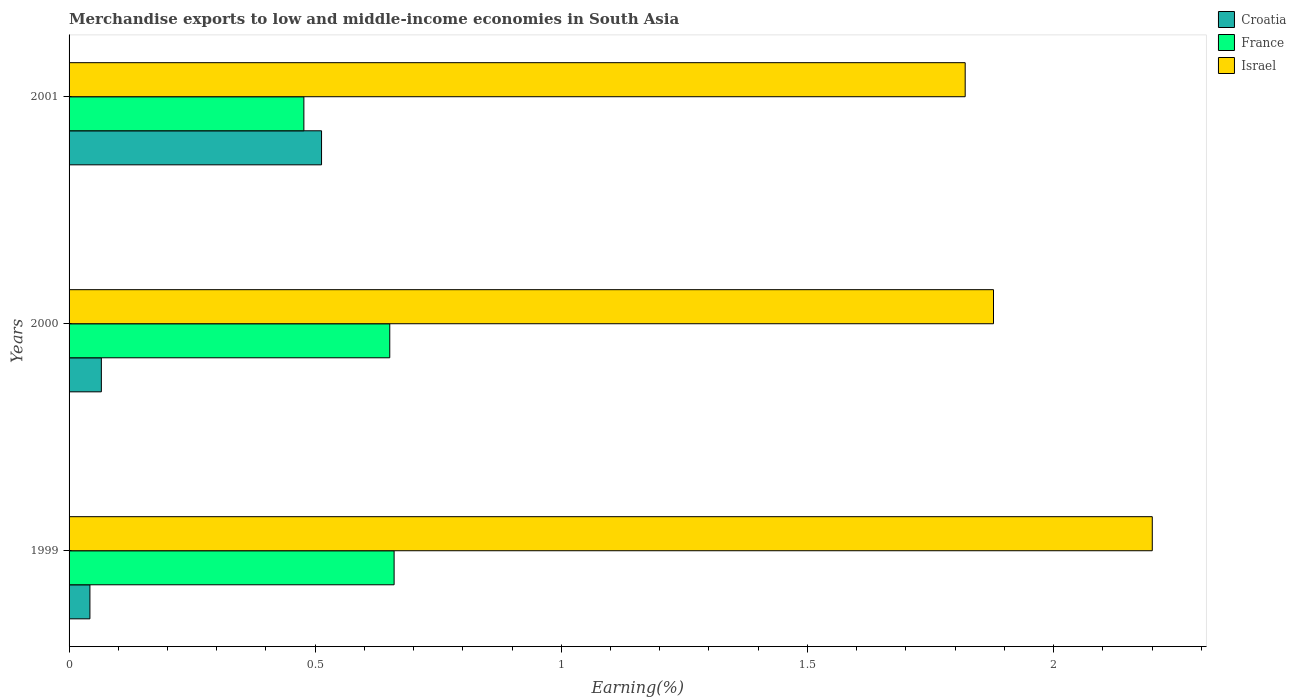Are the number of bars per tick equal to the number of legend labels?
Your answer should be compact. Yes. How many bars are there on the 1st tick from the top?
Keep it short and to the point. 3. What is the percentage of amount earned from merchandise exports in Israel in 2000?
Provide a short and direct response. 1.88. Across all years, what is the maximum percentage of amount earned from merchandise exports in Croatia?
Make the answer very short. 0.51. Across all years, what is the minimum percentage of amount earned from merchandise exports in France?
Your answer should be very brief. 0.48. What is the total percentage of amount earned from merchandise exports in Croatia in the graph?
Make the answer very short. 0.62. What is the difference between the percentage of amount earned from merchandise exports in France in 1999 and that in 2001?
Keep it short and to the point. 0.18. What is the difference between the percentage of amount earned from merchandise exports in Croatia in 2000 and the percentage of amount earned from merchandise exports in France in 2001?
Provide a succinct answer. -0.41. What is the average percentage of amount earned from merchandise exports in Croatia per year?
Your answer should be compact. 0.21. In the year 2000, what is the difference between the percentage of amount earned from merchandise exports in France and percentage of amount earned from merchandise exports in Croatia?
Make the answer very short. 0.59. What is the ratio of the percentage of amount earned from merchandise exports in France in 1999 to that in 2001?
Give a very brief answer. 1.38. Is the percentage of amount earned from merchandise exports in Israel in 1999 less than that in 2001?
Give a very brief answer. No. What is the difference between the highest and the second highest percentage of amount earned from merchandise exports in France?
Your response must be concise. 0.01. What is the difference between the highest and the lowest percentage of amount earned from merchandise exports in Israel?
Your answer should be very brief. 0.38. What does the 3rd bar from the top in 1999 represents?
Provide a succinct answer. Croatia. How many bars are there?
Provide a short and direct response. 9. Are all the bars in the graph horizontal?
Offer a very short reply. Yes. How many years are there in the graph?
Ensure brevity in your answer.  3. What is the difference between two consecutive major ticks on the X-axis?
Your answer should be compact. 0.5. Are the values on the major ticks of X-axis written in scientific E-notation?
Ensure brevity in your answer.  No. Does the graph contain any zero values?
Give a very brief answer. No. Where does the legend appear in the graph?
Your answer should be compact. Top right. How many legend labels are there?
Provide a short and direct response. 3. How are the legend labels stacked?
Your response must be concise. Vertical. What is the title of the graph?
Your answer should be compact. Merchandise exports to low and middle-income economies in South Asia. What is the label or title of the X-axis?
Provide a succinct answer. Earning(%). What is the Earning(%) in Croatia in 1999?
Your answer should be very brief. 0.04. What is the Earning(%) of France in 1999?
Ensure brevity in your answer.  0.66. What is the Earning(%) in Israel in 1999?
Your answer should be compact. 2.2. What is the Earning(%) of Croatia in 2000?
Offer a very short reply. 0.07. What is the Earning(%) of France in 2000?
Provide a short and direct response. 0.65. What is the Earning(%) of Israel in 2000?
Your response must be concise. 1.88. What is the Earning(%) of Croatia in 2001?
Make the answer very short. 0.51. What is the Earning(%) in France in 2001?
Ensure brevity in your answer.  0.48. What is the Earning(%) of Israel in 2001?
Your answer should be very brief. 1.82. Across all years, what is the maximum Earning(%) in Croatia?
Keep it short and to the point. 0.51. Across all years, what is the maximum Earning(%) of France?
Your answer should be compact. 0.66. Across all years, what is the maximum Earning(%) in Israel?
Ensure brevity in your answer.  2.2. Across all years, what is the minimum Earning(%) in Croatia?
Ensure brevity in your answer.  0.04. Across all years, what is the minimum Earning(%) of France?
Ensure brevity in your answer.  0.48. Across all years, what is the minimum Earning(%) of Israel?
Your answer should be very brief. 1.82. What is the total Earning(%) of Croatia in the graph?
Provide a succinct answer. 0.62. What is the total Earning(%) in France in the graph?
Your answer should be very brief. 1.79. What is the total Earning(%) of Israel in the graph?
Provide a succinct answer. 5.9. What is the difference between the Earning(%) in Croatia in 1999 and that in 2000?
Offer a very short reply. -0.02. What is the difference between the Earning(%) of France in 1999 and that in 2000?
Your answer should be compact. 0.01. What is the difference between the Earning(%) in Israel in 1999 and that in 2000?
Ensure brevity in your answer.  0.32. What is the difference between the Earning(%) in Croatia in 1999 and that in 2001?
Your response must be concise. -0.47. What is the difference between the Earning(%) in France in 1999 and that in 2001?
Offer a terse response. 0.18. What is the difference between the Earning(%) of Israel in 1999 and that in 2001?
Ensure brevity in your answer.  0.38. What is the difference between the Earning(%) in Croatia in 2000 and that in 2001?
Offer a terse response. -0.45. What is the difference between the Earning(%) of France in 2000 and that in 2001?
Keep it short and to the point. 0.17. What is the difference between the Earning(%) of Israel in 2000 and that in 2001?
Offer a very short reply. 0.06. What is the difference between the Earning(%) in Croatia in 1999 and the Earning(%) in France in 2000?
Your answer should be compact. -0.61. What is the difference between the Earning(%) in Croatia in 1999 and the Earning(%) in Israel in 2000?
Ensure brevity in your answer.  -1.84. What is the difference between the Earning(%) in France in 1999 and the Earning(%) in Israel in 2000?
Your answer should be compact. -1.22. What is the difference between the Earning(%) of Croatia in 1999 and the Earning(%) of France in 2001?
Offer a very short reply. -0.43. What is the difference between the Earning(%) of Croatia in 1999 and the Earning(%) of Israel in 2001?
Your response must be concise. -1.78. What is the difference between the Earning(%) in France in 1999 and the Earning(%) in Israel in 2001?
Your answer should be very brief. -1.16. What is the difference between the Earning(%) in Croatia in 2000 and the Earning(%) in France in 2001?
Give a very brief answer. -0.41. What is the difference between the Earning(%) of Croatia in 2000 and the Earning(%) of Israel in 2001?
Your answer should be compact. -1.75. What is the difference between the Earning(%) of France in 2000 and the Earning(%) of Israel in 2001?
Keep it short and to the point. -1.17. What is the average Earning(%) of Croatia per year?
Offer a very short reply. 0.21. What is the average Earning(%) in France per year?
Ensure brevity in your answer.  0.6. What is the average Earning(%) of Israel per year?
Your answer should be compact. 1.97. In the year 1999, what is the difference between the Earning(%) of Croatia and Earning(%) of France?
Keep it short and to the point. -0.62. In the year 1999, what is the difference between the Earning(%) of Croatia and Earning(%) of Israel?
Provide a succinct answer. -2.16. In the year 1999, what is the difference between the Earning(%) of France and Earning(%) of Israel?
Keep it short and to the point. -1.54. In the year 2000, what is the difference between the Earning(%) of Croatia and Earning(%) of France?
Keep it short and to the point. -0.59. In the year 2000, what is the difference between the Earning(%) in Croatia and Earning(%) in Israel?
Provide a succinct answer. -1.81. In the year 2000, what is the difference between the Earning(%) in France and Earning(%) in Israel?
Provide a short and direct response. -1.23. In the year 2001, what is the difference between the Earning(%) of Croatia and Earning(%) of France?
Your answer should be very brief. 0.04. In the year 2001, what is the difference between the Earning(%) of Croatia and Earning(%) of Israel?
Offer a terse response. -1.31. In the year 2001, what is the difference between the Earning(%) of France and Earning(%) of Israel?
Provide a short and direct response. -1.34. What is the ratio of the Earning(%) of Croatia in 1999 to that in 2000?
Your response must be concise. 0.65. What is the ratio of the Earning(%) in France in 1999 to that in 2000?
Make the answer very short. 1.01. What is the ratio of the Earning(%) of Israel in 1999 to that in 2000?
Offer a terse response. 1.17. What is the ratio of the Earning(%) in Croatia in 1999 to that in 2001?
Offer a very short reply. 0.08. What is the ratio of the Earning(%) in France in 1999 to that in 2001?
Your response must be concise. 1.38. What is the ratio of the Earning(%) of Israel in 1999 to that in 2001?
Provide a succinct answer. 1.21. What is the ratio of the Earning(%) in Croatia in 2000 to that in 2001?
Your answer should be compact. 0.13. What is the ratio of the Earning(%) of France in 2000 to that in 2001?
Offer a terse response. 1.37. What is the ratio of the Earning(%) of Israel in 2000 to that in 2001?
Offer a very short reply. 1.03. What is the difference between the highest and the second highest Earning(%) of Croatia?
Make the answer very short. 0.45. What is the difference between the highest and the second highest Earning(%) of France?
Ensure brevity in your answer.  0.01. What is the difference between the highest and the second highest Earning(%) in Israel?
Your answer should be compact. 0.32. What is the difference between the highest and the lowest Earning(%) of Croatia?
Make the answer very short. 0.47. What is the difference between the highest and the lowest Earning(%) of France?
Offer a terse response. 0.18. What is the difference between the highest and the lowest Earning(%) of Israel?
Your answer should be very brief. 0.38. 